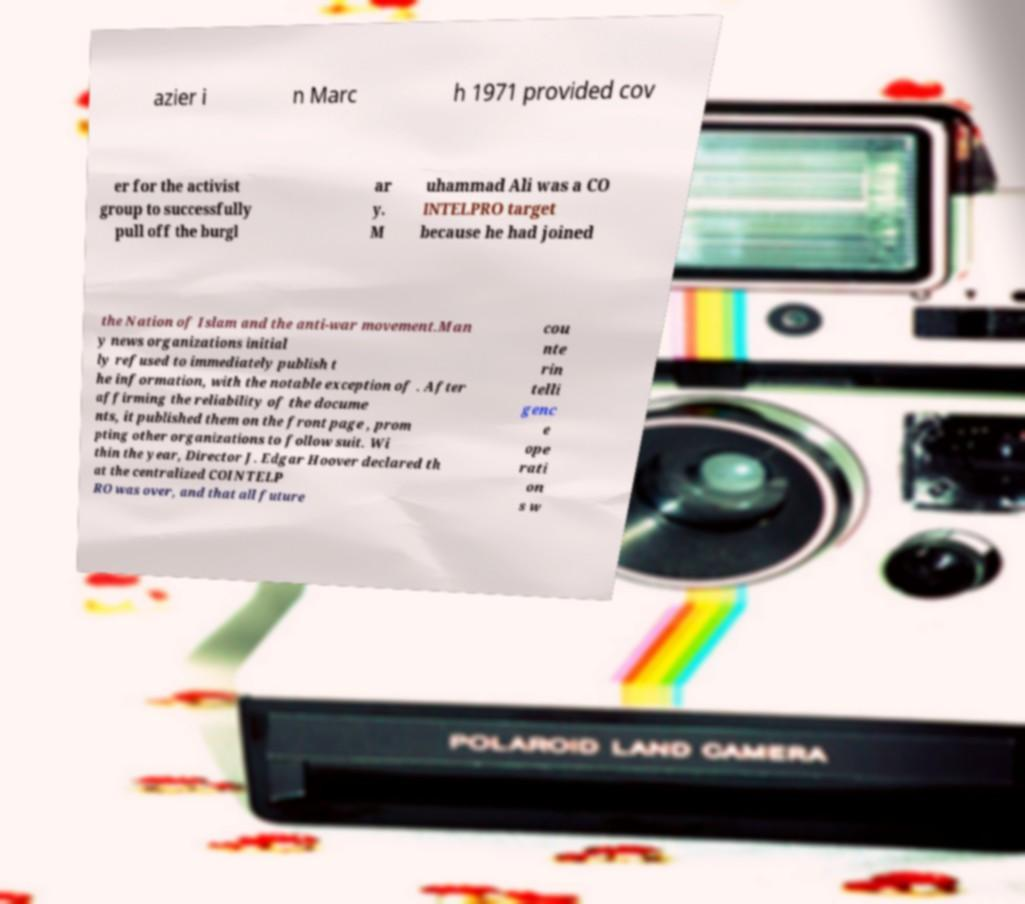Could you assist in decoding the text presented in this image and type it out clearly? azier i n Marc h 1971 provided cov er for the activist group to successfully pull off the burgl ar y. M uhammad Ali was a CO INTELPRO target because he had joined the Nation of Islam and the anti-war movement.Man y news organizations initial ly refused to immediately publish t he information, with the notable exception of . After affirming the reliability of the docume nts, it published them on the front page , prom pting other organizations to follow suit. Wi thin the year, Director J. Edgar Hoover declared th at the centralized COINTELP RO was over, and that all future cou nte rin telli genc e ope rati on s w 